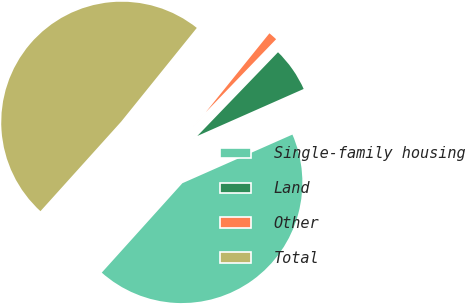<chart> <loc_0><loc_0><loc_500><loc_500><pie_chart><fcel>Single-family housing<fcel>Land<fcel>Other<fcel>Total<nl><fcel>43.3%<fcel>6.17%<fcel>1.4%<fcel>49.13%<nl></chart> 